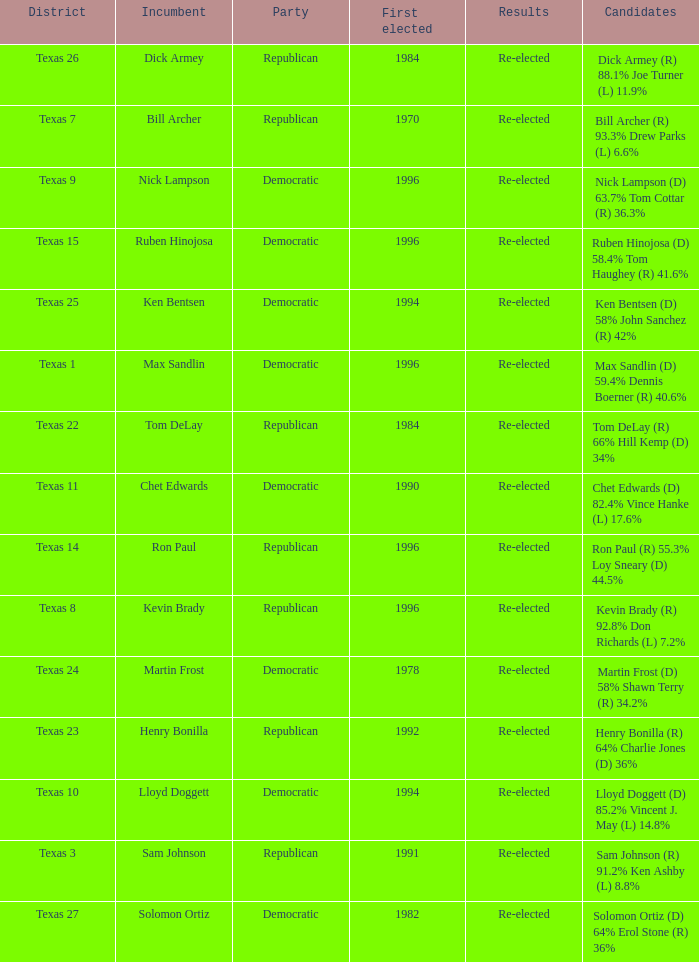What district is nick lampson from? Texas 9. 